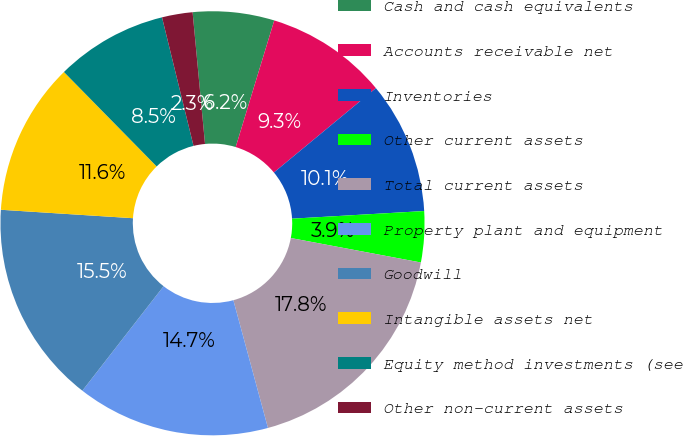<chart> <loc_0><loc_0><loc_500><loc_500><pie_chart><fcel>Cash and cash equivalents<fcel>Accounts receivable net<fcel>Inventories<fcel>Other current assets<fcel>Total current assets<fcel>Property plant and equipment<fcel>Goodwill<fcel>Intangible assets net<fcel>Equity method investments (see<fcel>Other non-current assets<nl><fcel>6.2%<fcel>9.3%<fcel>10.08%<fcel>3.88%<fcel>17.83%<fcel>14.73%<fcel>15.5%<fcel>11.63%<fcel>8.53%<fcel>2.33%<nl></chart> 